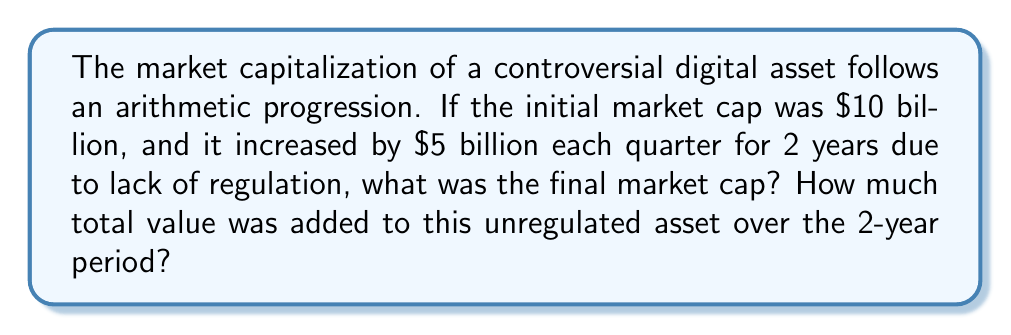Provide a solution to this math problem. Let's approach this step-by-step:

1) First, let's identify the components of the arithmetic progression:
   - Initial term (a₁) = $10 billion
   - Common difference (d) = $5 billion
   - Number of terms (n) = 8 (2 years = 8 quarters)

2) To find the final market cap, we need to find the 8th term of the progression. We can use the arithmetic sequence formula:

   $$a_n = a_1 + (n-1)d$$

   Where $a_n$ is the nth term, $a_1$ is the first term, n is the number of terms, and d is the common difference.

3) Plugging in our values:

   $$a_8 = 10 + (8-1)5 = 10 + 35 = 45$$

   So, the final market cap is $45 billion.

4) To find the total value added, we need to calculate the difference between the final and initial market caps:

   $$45 - 10 = 35$$

   Therefore, $35 billion was added over the 2-year period.

5) We can verify this using the arithmetic series formula to calculate the total value:

   $$S_n = \frac{n}{2}(a_1 + a_n) = \frac{8}{2}(10 + 45) = 4(55) = 220$$

   The total value after 2 years is $220 billion. Subtracting the initial $10 billion confirms that $35 billion was added.
Answer: $45 billion; $35 billion 